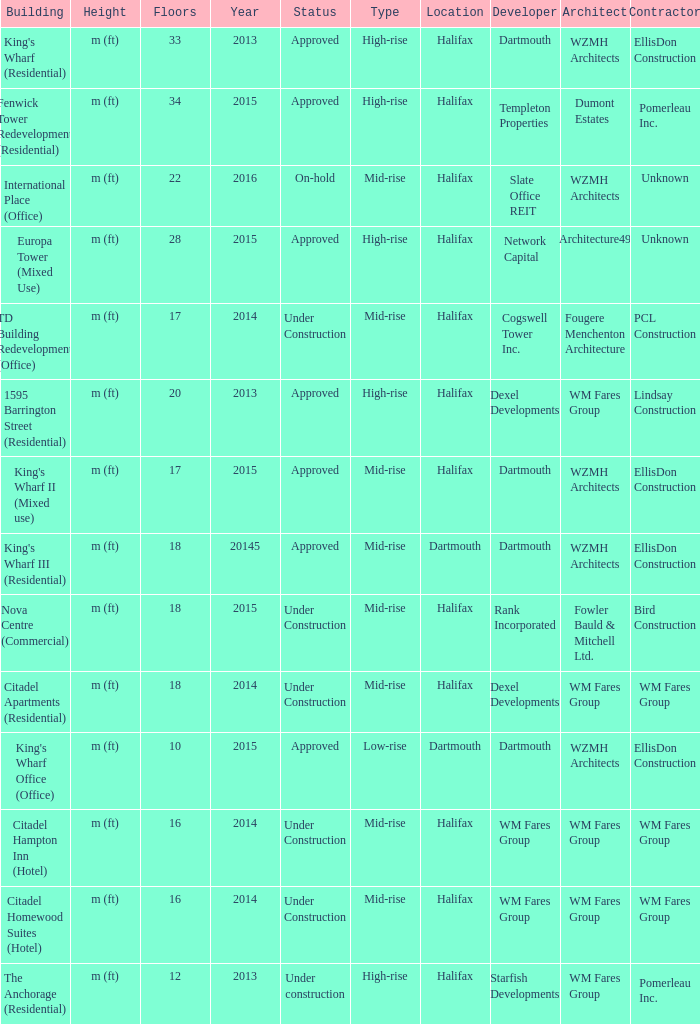Parse the full table. {'header': ['Building', 'Height', 'Floors', 'Year', 'Status', 'Type', 'Location', 'Developer', 'Architect', 'Contractor'], 'rows': [["King's Wharf (Residential)", 'm (ft)', '33', '2013', 'Approved', 'High-rise', 'Halifax', 'Dartmouth', 'WZMH Architects', 'EllisDon Construction'], ['Fenwick Tower Redevelopment (Residential)', 'm (ft)', '34', '2015', 'Approved', 'High-rise', 'Halifax', 'Templeton Properties', 'Dumont Estates', 'Pomerleau Inc.'], ['International Place (Office)', 'm (ft)', '22', '2016', 'On-hold', 'Mid-rise', 'Halifax', 'Slate Office REIT', 'WZMH Architects', 'Unknown'], ['Europa Tower (Mixed Use)', 'm (ft)', '28', '2015', 'Approved', 'High-rise', 'Halifax', 'Network Capital', 'Architecture49', 'Unknown'], ['TD Building Redevelopment (Office)', 'm (ft)', '17', '2014', 'Under Construction', 'Mid-rise', 'Halifax', 'Cogswell Tower Inc.', 'Fougere Menchenton Architecture', 'PCL Construction'], ['1595 Barrington Street (Residential)', 'm (ft)', '20', '2013', 'Approved', 'High-rise', 'Halifax', 'Dexel Developments', 'WM Fares Group', 'Lindsay Construction'], ["King's Wharf II (Mixed use)", 'm (ft)', '17', '2015', 'Approved', 'Mid-rise', 'Halifax', 'Dartmouth', 'WZMH Architects', 'EllisDon Construction'], ["King's Wharf III (Residential)", 'm (ft)', '18', '20145', 'Approved', 'Mid-rise', 'Dartmouth', 'Dartmouth', 'WZMH Architects', 'EllisDon Construction'], ['Nova Centre (Commercial)', 'm (ft)', '18', '2015', 'Under Construction', 'Mid-rise', 'Halifax', 'Rank Incorporated', 'Fowler Bauld & Mitchell Ltd.', 'Bird Construction'], ['Citadel Apartments (Residential)', 'm (ft)', '18', '2014', 'Under Construction', 'Mid-rise', 'Halifax', 'Dexel Developments', 'WM Fares Group', 'WM Fares Group'], ["King's Wharf Office (Office)", 'm (ft)', '10', '2015', 'Approved', 'Low-rise', 'Dartmouth', 'Dartmouth', 'WZMH Architects', 'EllisDon Construction'], ['Citadel Hampton Inn (Hotel)', 'm (ft)', '16', '2014', 'Under Construction', 'Mid-rise', 'Halifax', 'WM Fares Group', 'WM Fares Group', 'WM Fares Group'], ['Citadel Homewood Suites (Hotel)', 'm (ft)', '16', '2014', 'Under Construction', 'Mid-rise', 'Halifax', 'WM Fares Group', 'WM Fares Group', 'WM Fares Group'], ['The Anchorage (Residential)', 'm (ft)', '12', '2013', 'Under construction', 'High-rise', 'Halifax', 'Starfish Developments', 'WM Fares Group', 'Pomerleau Inc.']]} What are the number of floors for the building of td building redevelopment (office)? 17.0. 